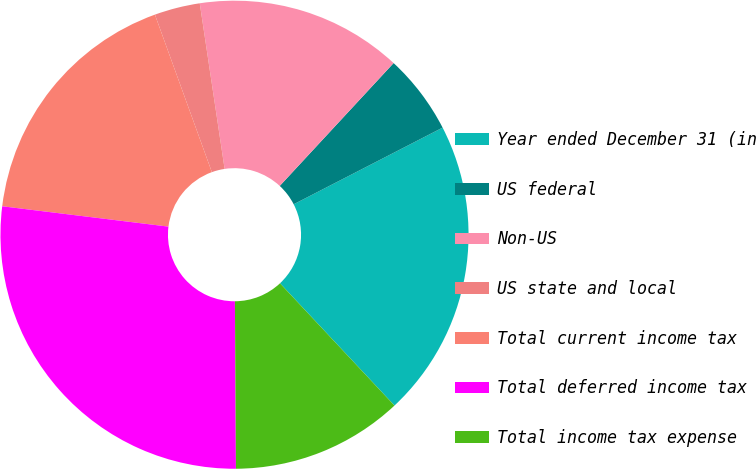Convert chart to OTSL. <chart><loc_0><loc_0><loc_500><loc_500><pie_chart><fcel>Year ended December 31 (in<fcel>US federal<fcel>Non-US<fcel>US state and local<fcel>Total current income tax<fcel>Total deferred income tax<fcel>Total income tax expense<nl><fcel>20.59%<fcel>5.54%<fcel>14.27%<fcel>3.15%<fcel>17.54%<fcel>27.04%<fcel>11.88%<nl></chart> 